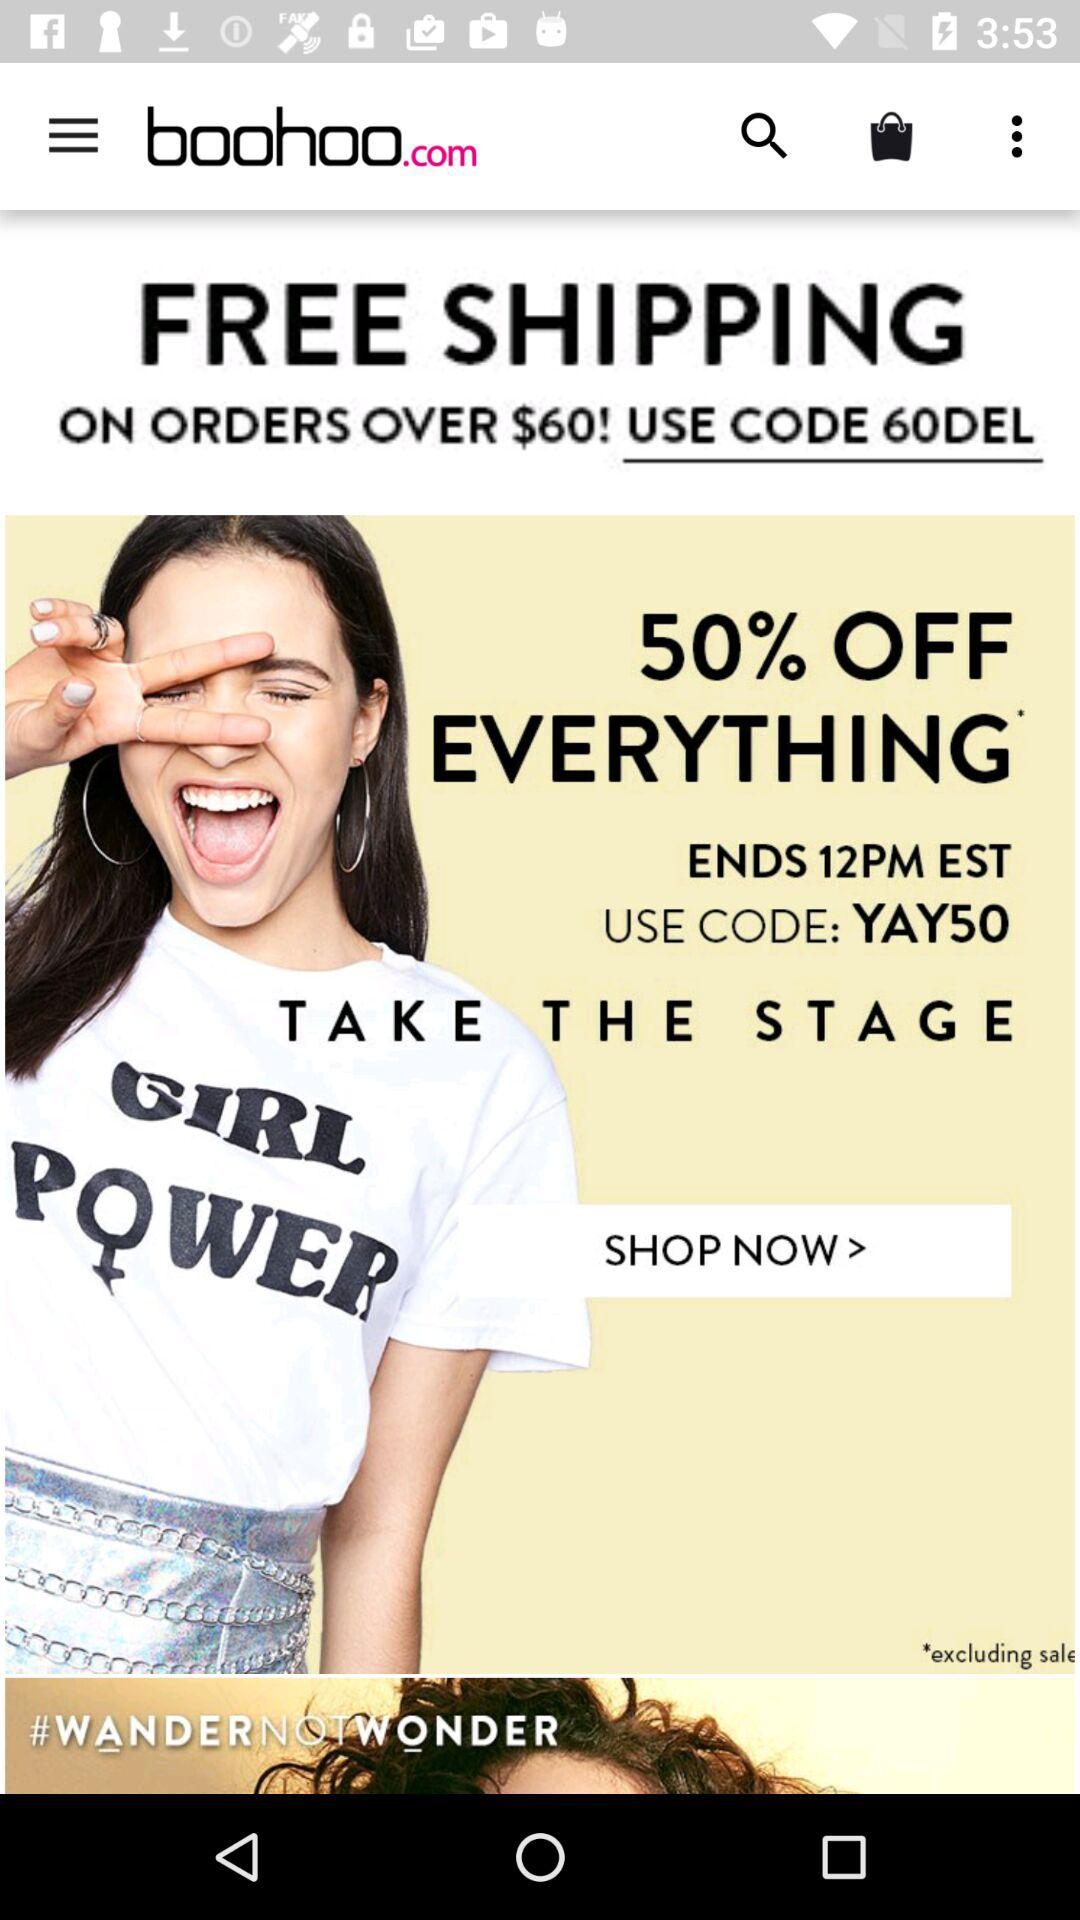When will the free shipping apply? Free shipping will apply to orders over $60. 